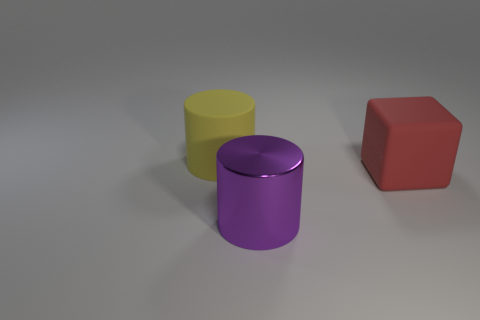Subtract all yellow cylinders. How many cylinders are left? 1 Subtract all cylinders. How many objects are left? 1 Add 3 yellow matte cubes. How many objects exist? 6 Subtract 1 cylinders. How many cylinders are left? 1 Subtract all small green shiny things. Subtract all big rubber things. How many objects are left? 1 Add 2 metal cylinders. How many metal cylinders are left? 3 Add 3 large yellow matte cylinders. How many large yellow matte cylinders exist? 4 Subtract 0 gray spheres. How many objects are left? 3 Subtract all yellow cylinders. Subtract all red balls. How many cylinders are left? 1 Subtract all cyan balls. How many purple cylinders are left? 1 